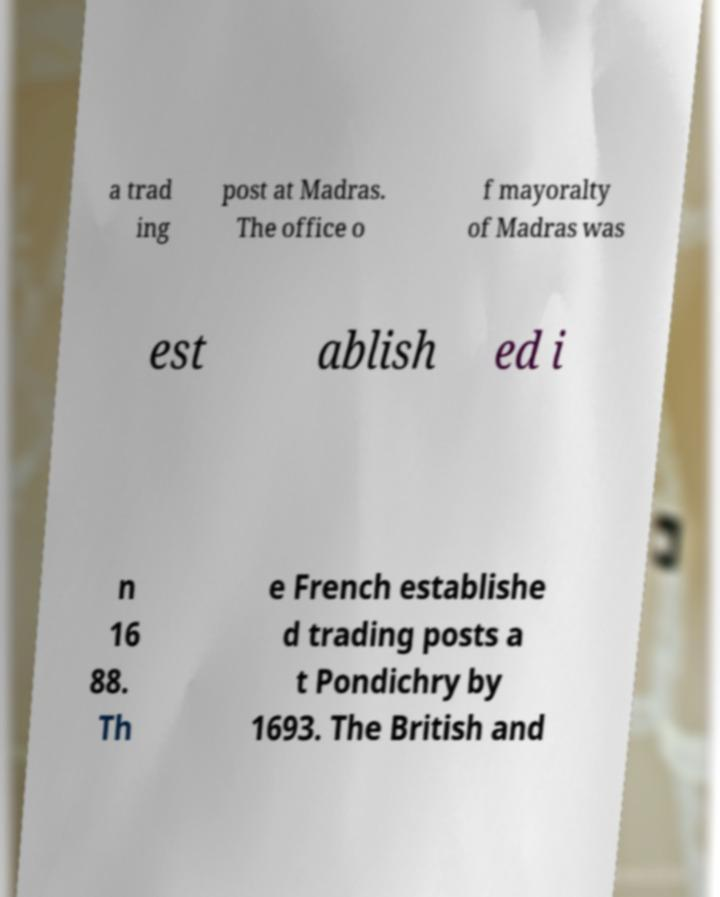Could you extract and type out the text from this image? a trad ing post at Madras. The office o f mayoralty of Madras was est ablish ed i n 16 88. Th e French establishe d trading posts a t Pondichry by 1693. The British and 